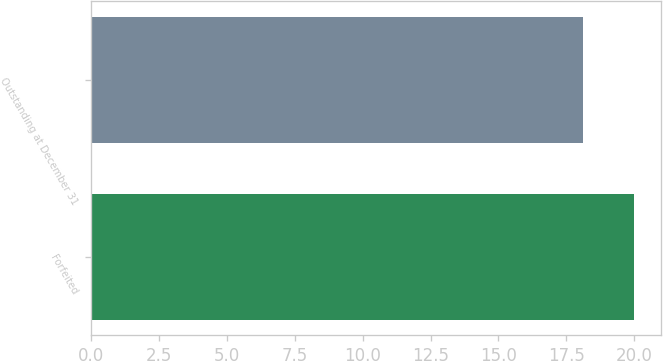Convert chart to OTSL. <chart><loc_0><loc_0><loc_500><loc_500><bar_chart><fcel>Forfeited<fcel>Outstanding at December 31<nl><fcel>19.99<fcel>18.13<nl></chart> 